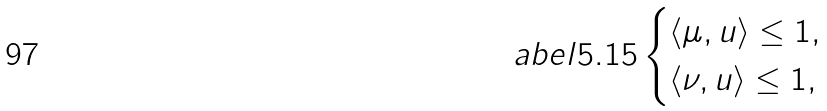<formula> <loc_0><loc_0><loc_500><loc_500>\L a b e l { 5 . 1 5 } \begin{cases} \langle \mu , u \rangle \leq 1 , \\ \langle \nu , u \rangle \leq 1 , \end{cases}</formula> 